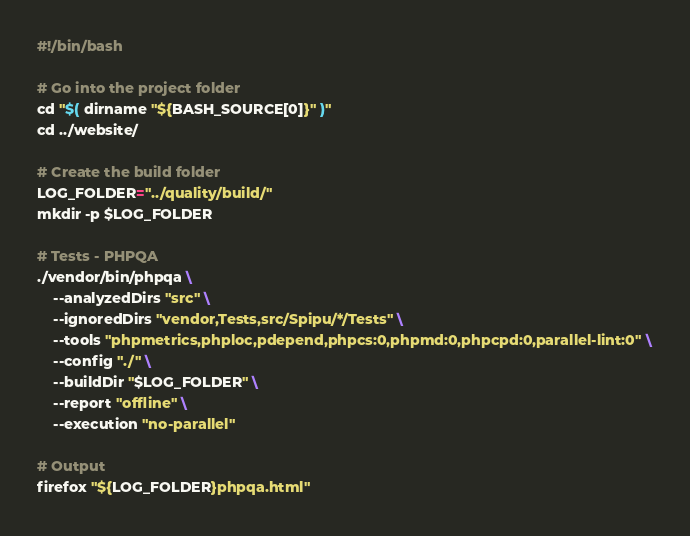Convert code to text. <code><loc_0><loc_0><loc_500><loc_500><_Bash_>#!/bin/bash

# Go into the project folder
cd "$( dirname "${BASH_SOURCE[0]}" )"
cd ../website/

# Create the build folder
LOG_FOLDER="../quality/build/"
mkdir -p $LOG_FOLDER

# Tests - PHPQA
./vendor/bin/phpqa \
    --analyzedDirs "src" \
    --ignoredDirs "vendor,Tests,src/Spipu/*/Tests" \
    --tools "phpmetrics,phploc,pdepend,phpcs:0,phpmd:0,phpcpd:0,parallel-lint:0" \
    --config "./" \
    --buildDir "$LOG_FOLDER" \
    --report "offline" \
    --execution "no-parallel"

# Output
firefox "${LOG_FOLDER}phpqa.html"
</code> 